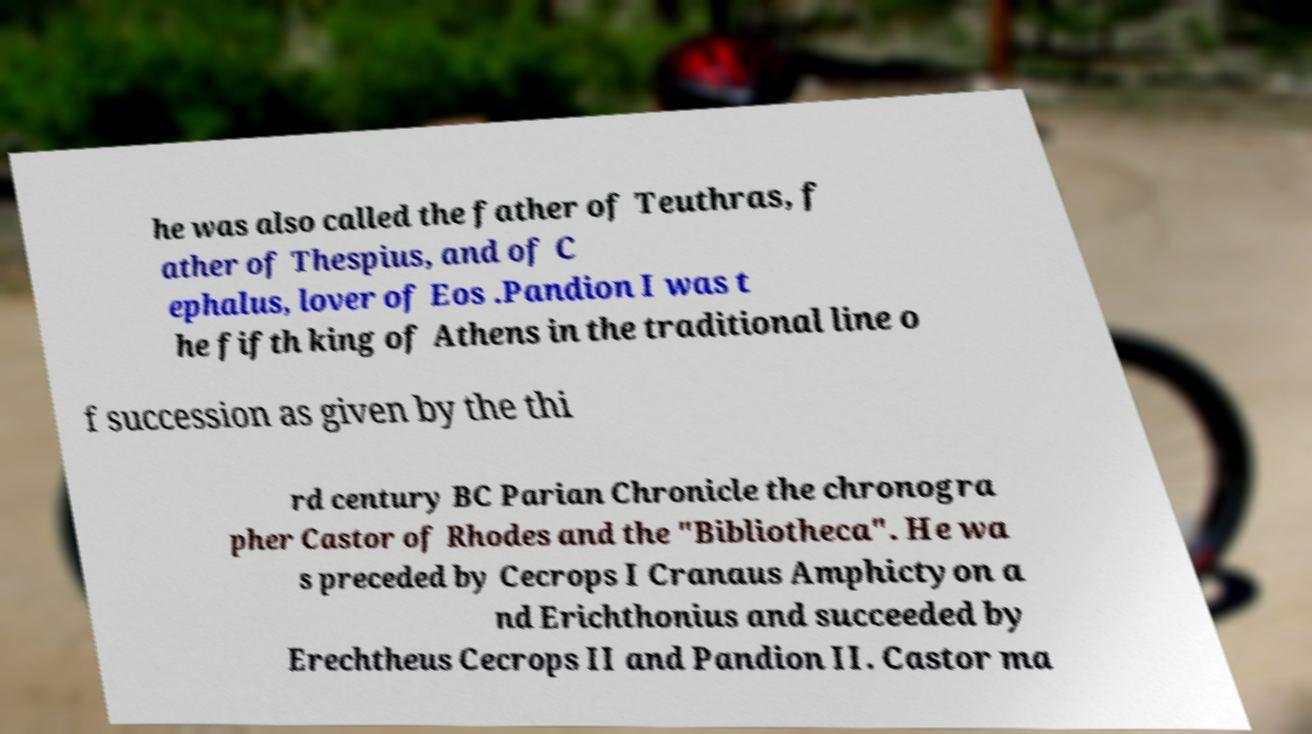There's text embedded in this image that I need extracted. Can you transcribe it verbatim? he was also called the father of Teuthras, f ather of Thespius, and of C ephalus, lover of Eos .Pandion I was t he fifth king of Athens in the traditional line o f succession as given by the thi rd century BC Parian Chronicle the chronogra pher Castor of Rhodes and the "Bibliotheca". He wa s preceded by Cecrops I Cranaus Amphictyon a nd Erichthonius and succeeded by Erechtheus Cecrops II and Pandion II. Castor ma 